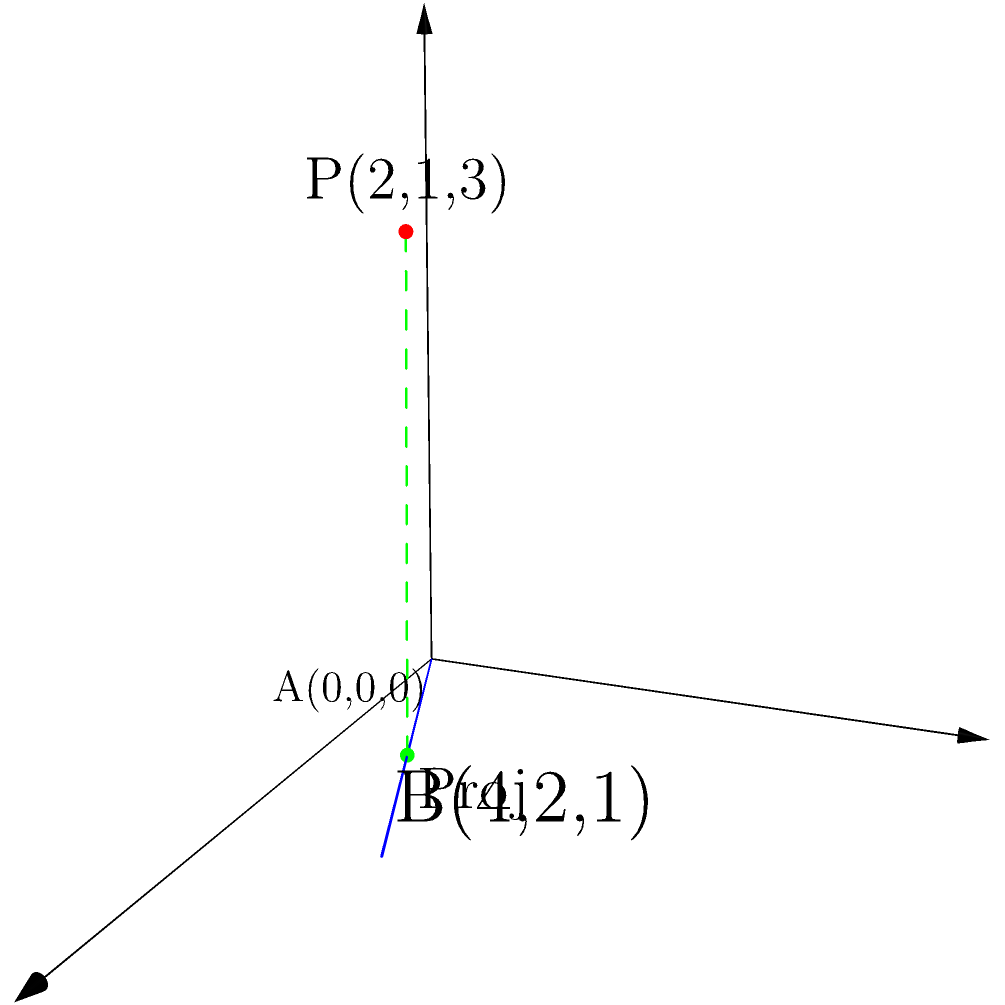En una escena 3D, necesitas calcular la distancia más corta entre un punto P(2,1,3) y una línea que pasa por los puntos A(0,0,0) y B(4,2,1). Esta distancia es crucial para posicionar correctamente un objeto en relación con otros elementos de la escena. ¿Cuál es la distancia entre el punto P y la línea AB? Para calcular la distancia entre un punto y una línea en 3D, seguiremos estos pasos:

1) La línea está definida por dos puntos: A(0,0,0) y B(4,2,1).
   El vector director de la línea es $\vec{v} = B - A = (4,2,1)$.

2) El vector desde A hasta P es $\vec{AP} = P - A = (2,1,3)$.

3) La fórmula para la distancia d es:

   $$d = \frac{|\vec{AP} \times \vec{v}|}{|\vec{v}|}$$

   donde $\times$ denota el producto vectorial y $|...|$ la magnitud del vector.

4) Calculemos el producto vectorial $\vec{AP} \times \vec{v}$:
   $$\vec{AP} \times \vec{v} = (1 \cdot 1 - 3 \cdot 2, 3 \cdot 4 - 2 \cdot 1, 2 \cdot 2 - 1 \cdot 4) = (-5, 11, 0)$$

5) La magnitud de este vector es:
   $$|\vec{AP} \times \vec{v}| = \sqrt{(-5)^2 + 11^2 + 0^2} = \sqrt{146}$$

6) La magnitud de $\vec{v}$ es:
   $$|\vec{v}| = \sqrt{4^2 + 2^2 + 1^2} = \sqrt{21}$$

7) Finalmente, calculamos la distancia:
   $$d = \frac{\sqrt{146}}{\sqrt{21}} = \sqrt{\frac{146}{21}}$$
Answer: $\sqrt{\frac{146}{21}}$ 